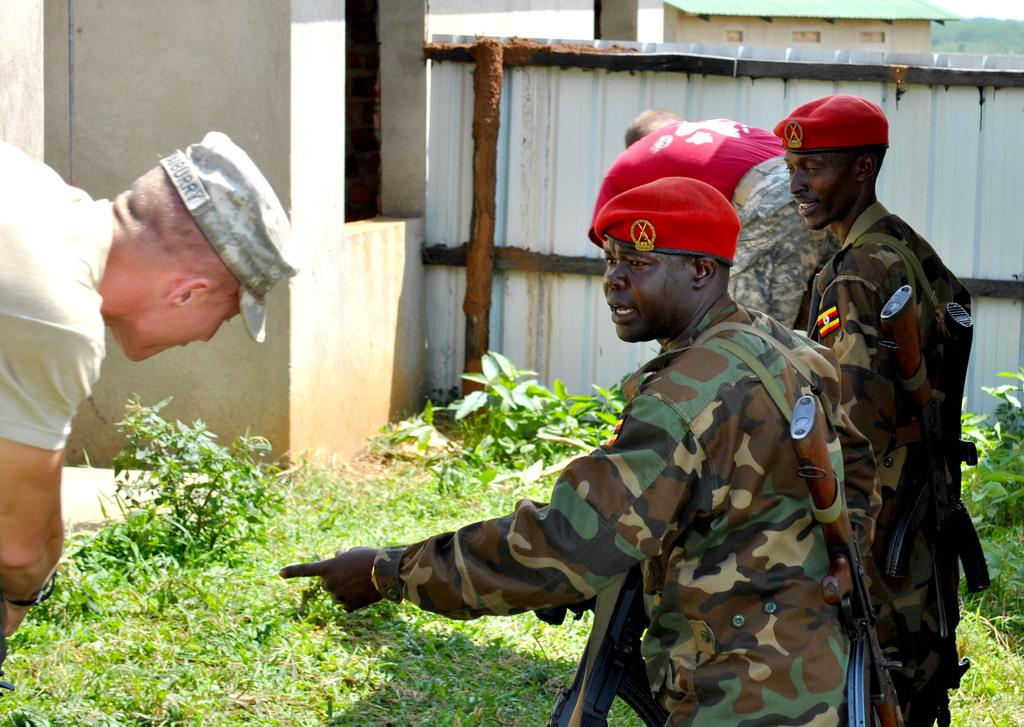How many people are present in the image? There are four persons in the image. What type of natural environment is visible in the image? There is grass and plants visible in the image. What type of structure can be seen in the image? There is a wall and a shed in the image. What type of roofing material is present in the image? There is a roof sheet in the image. What type of cloud can be seen in the image? There are no clouds visible in the image. How many passengers are present in the image? There is no indication of passengers in the image, as it features four persons but does not specify if they are passengers or not. 